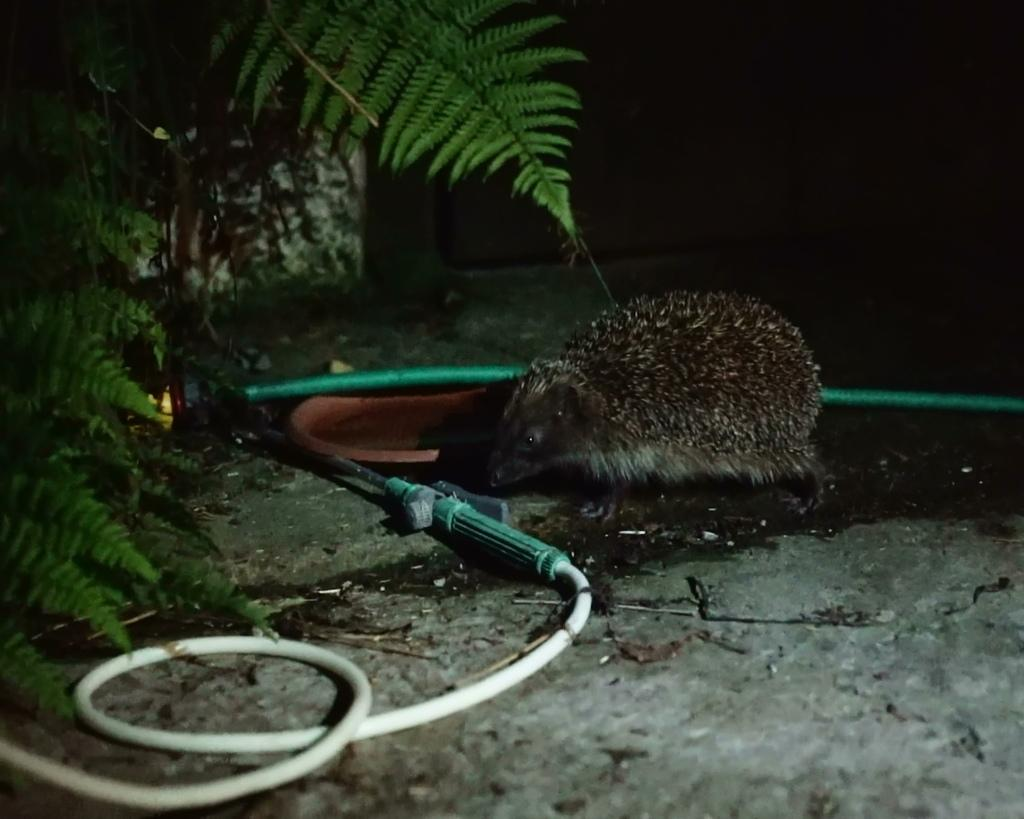What is the main subject in the middle of the image? There is a rat in the middle of the image. What can be seen on the left side of the image? There are leaves of a tree on the left side of the image. What type of fish is swimming in the story depicted in the image? There is no fish or story present in the image; it features a rat and leaves of a tree. 